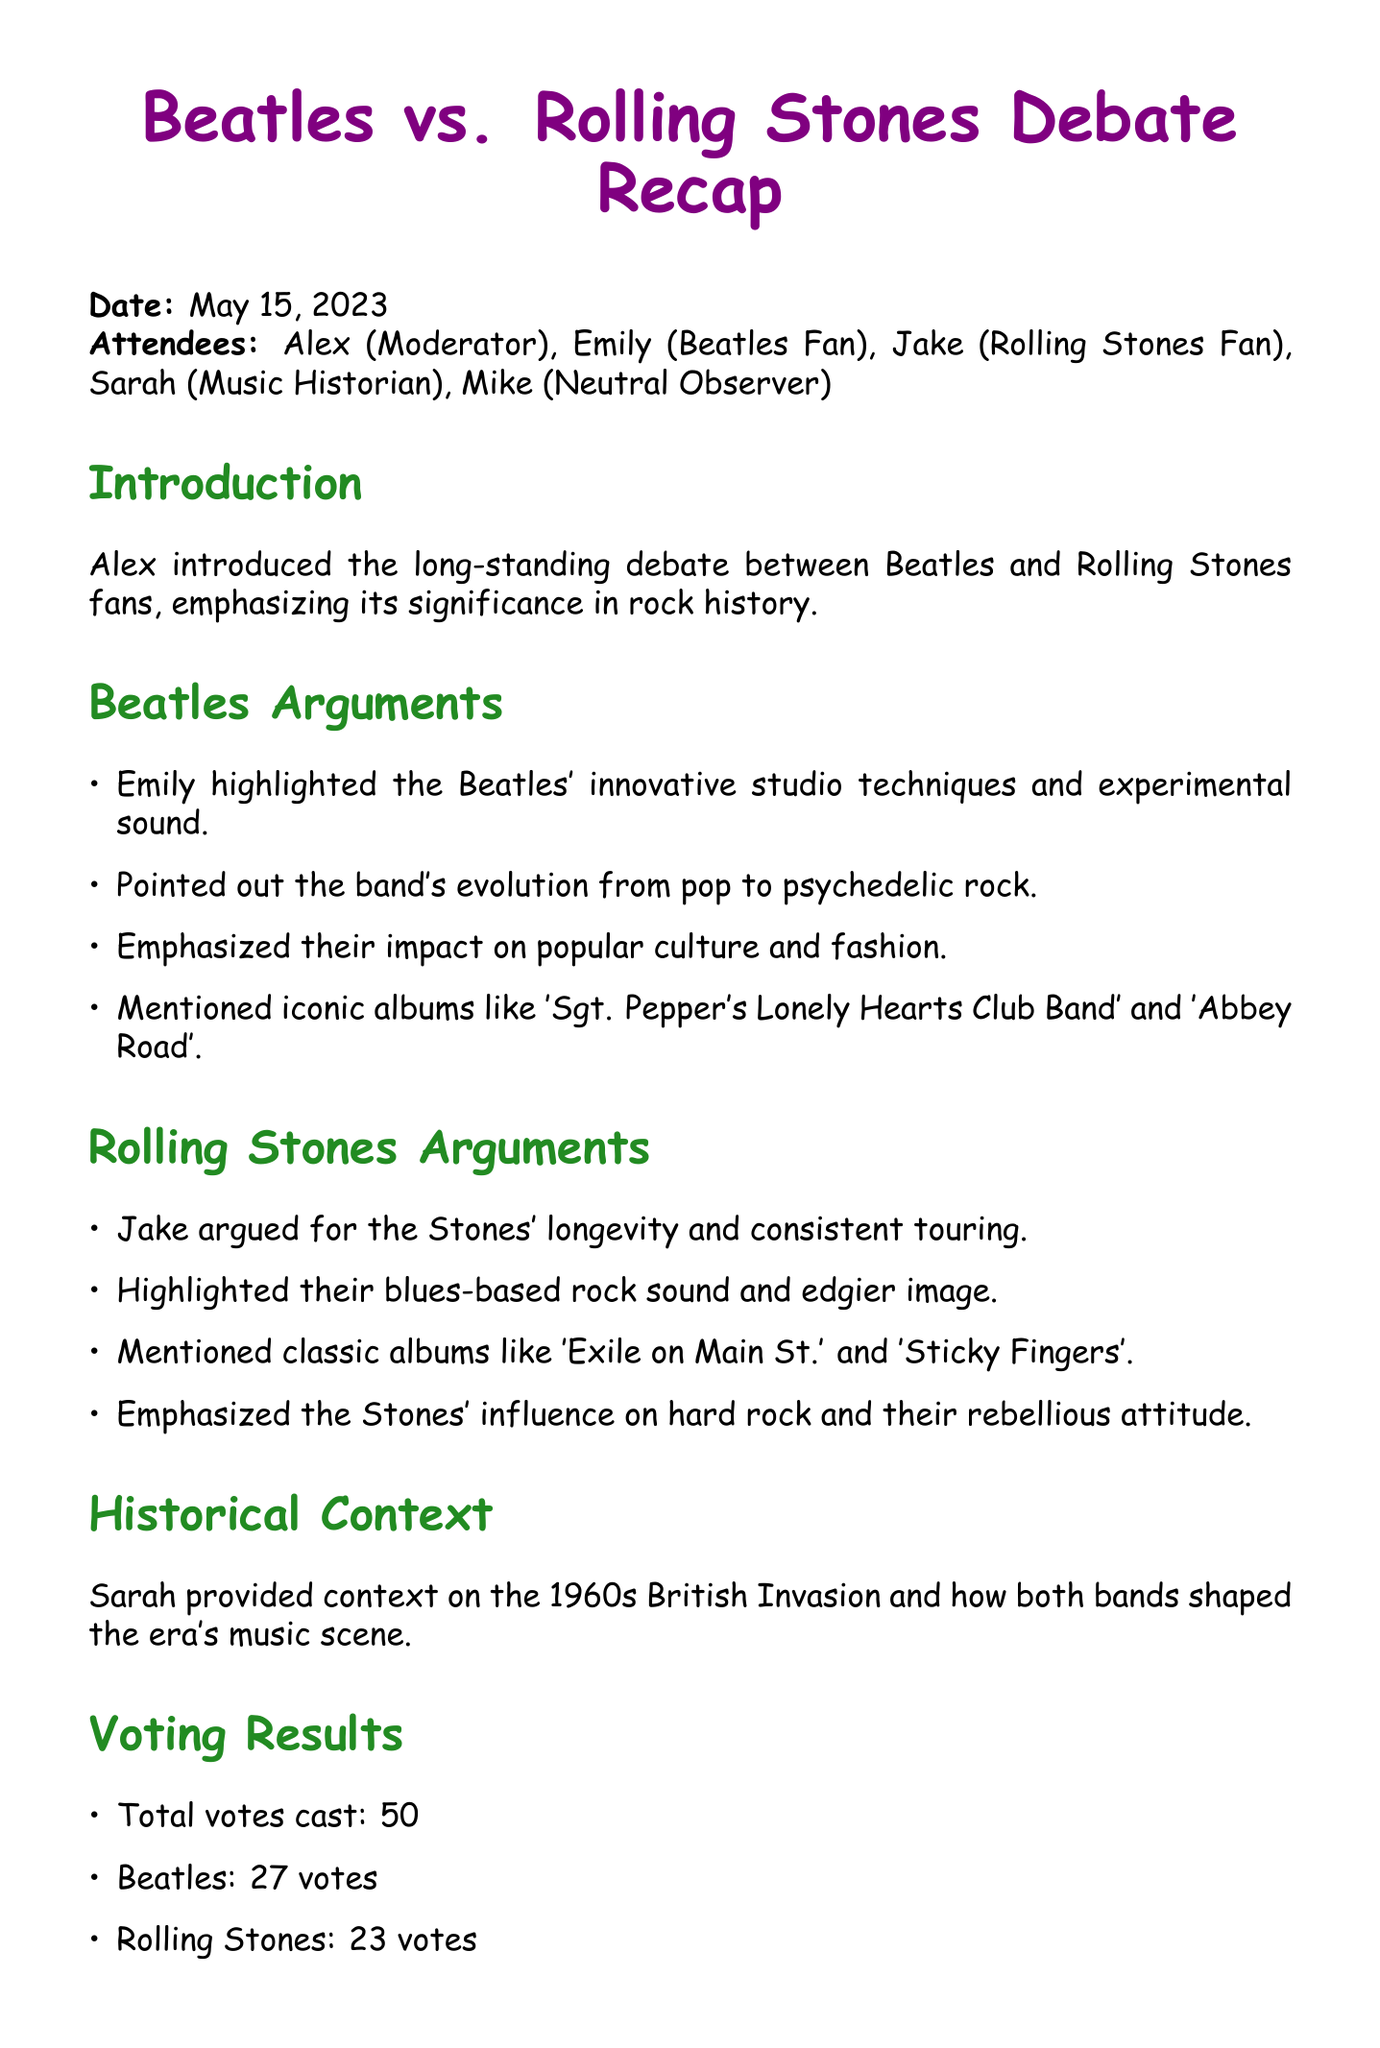What is the date of the meeting? The date of the meeting is specified in the document as May 15, 2023.
Answer: May 15, 2023 Who moderated the debate? The name of the person who moderated the debate is listed in the attendees section. It was Alex.
Answer: Alex What are two iconic Beatles albums mentioned? The document lists two specific albums that are considered iconic from the Beatles' discography. They are 'Sgt. Pepper's Lonely Hearts Club Band' and 'Abbey Road'.
Answer: 'Sgt. Pepper's Lonely Hearts Club Band' and 'Abbey Road' How many total votes were cast in the debate? The total number of votes cast is specifically referenced in the voting results section of the document.
Answer: 50 Which band's arguments emphasized a blues-based rock sound? The document identifies which band's arguments focused on their blues influence based on the points made during the debate.
Answer: Rolling Stones What was the final vote tally for the Beatles? The document states the number of votes the Beatles received in the voting results, which can be found in the relevant section.
Answer: 27 votes Who provided historical context during the meeting? The document attributes the task of providing historical context to a specific attendee, mentioned in the meeting minutes.
Answer: Sarah What was one of the action items decided at the end of the meeting? One specific action item is detailed in the action items section at the end of the document. It relates to organizing a listening event for the discussed bands.
Answer: Organize a listening party featuring albums from both bands 